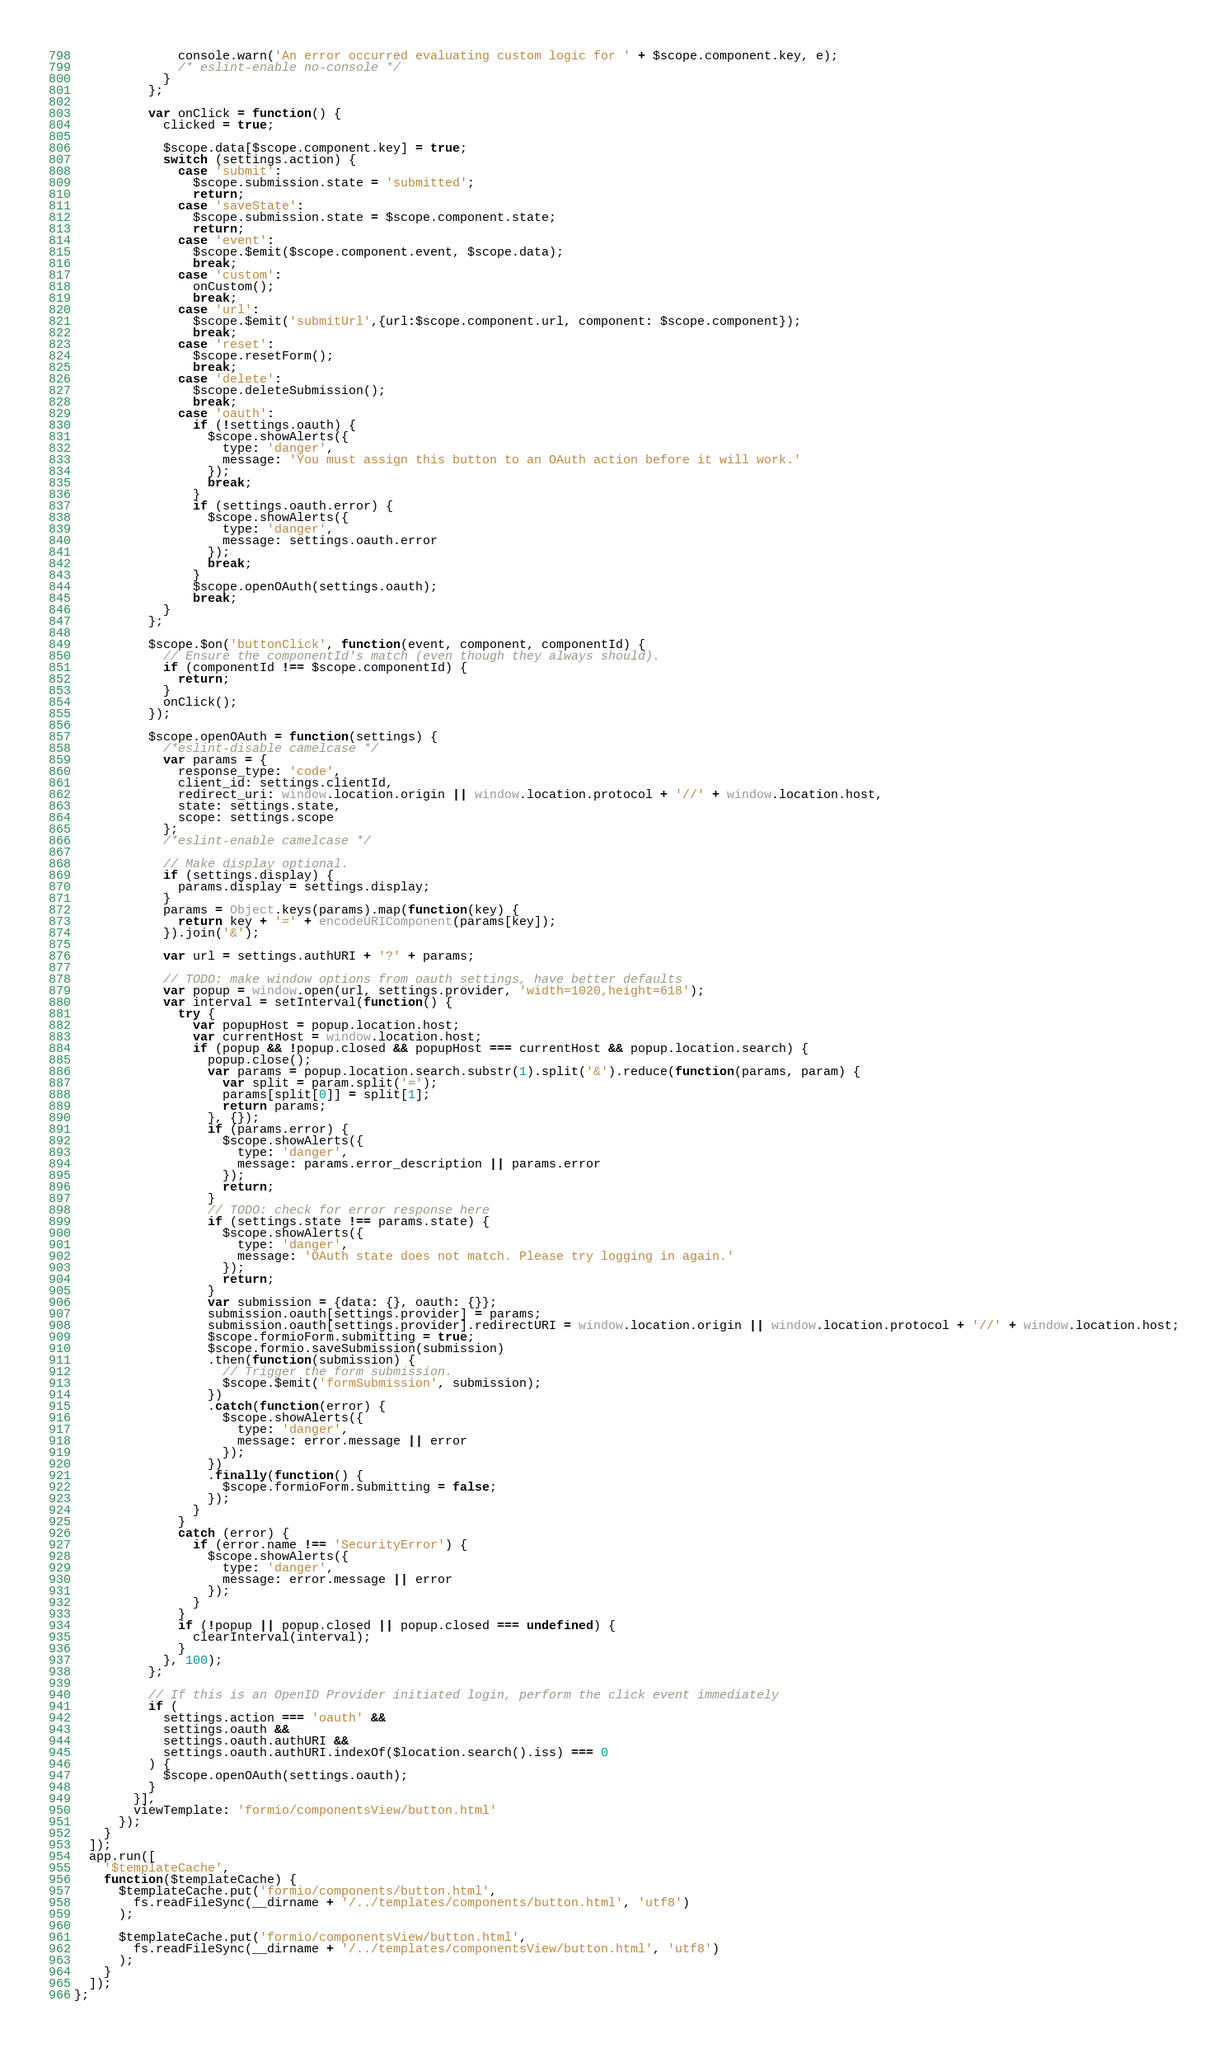<code> <loc_0><loc_0><loc_500><loc_500><_JavaScript_>              console.warn('An error occurred evaluating custom logic for ' + $scope.component.key, e);
              /* eslint-enable no-console */
            }
          };

          var onClick = function() {
            clicked = true;

            $scope.data[$scope.component.key] = true;
            switch (settings.action) {
              case 'submit':
                $scope.submission.state = 'submitted';
                return;
              case 'saveState':
                $scope.submission.state = $scope.component.state;
                return;
              case 'event':
                $scope.$emit($scope.component.event, $scope.data);
                break;
              case 'custom':
                onCustom();
                break;
              case 'url':
                $scope.$emit('submitUrl',{url:$scope.component.url, component: $scope.component});
                break;
              case 'reset':
                $scope.resetForm();
                break;
              case 'delete':
                $scope.deleteSubmission();
                break;
              case 'oauth':
                if (!settings.oauth) {
                  $scope.showAlerts({
                    type: 'danger',
                    message: 'You must assign this button to an OAuth action before it will work.'
                  });
                  break;
                }
                if (settings.oauth.error) {
                  $scope.showAlerts({
                    type: 'danger',
                    message: settings.oauth.error
                  });
                  break;
                }
                $scope.openOAuth(settings.oauth);
                break;
            }
          };

          $scope.$on('buttonClick', function(event, component, componentId) {
            // Ensure the componentId's match (even though they always should).
            if (componentId !== $scope.componentId) {
              return;
            }
            onClick();
          });

          $scope.openOAuth = function(settings) {
            /*eslint-disable camelcase */
            var params = {
              response_type: 'code',
              client_id: settings.clientId,
              redirect_uri: window.location.origin || window.location.protocol + '//' + window.location.host,
              state: settings.state,
              scope: settings.scope
            };
            /*eslint-enable camelcase */

            // Make display optional.
            if (settings.display) {
              params.display = settings.display;
            }
            params = Object.keys(params).map(function(key) {
              return key + '=' + encodeURIComponent(params[key]);
            }).join('&');

            var url = settings.authURI + '?' + params;

            // TODO: make window options from oauth settings, have better defaults
            var popup = window.open(url, settings.provider, 'width=1020,height=618');
            var interval = setInterval(function() {
              try {
                var popupHost = popup.location.host;
                var currentHost = window.location.host;
                if (popup && !popup.closed && popupHost === currentHost && popup.location.search) {
                  popup.close();
                  var params = popup.location.search.substr(1).split('&').reduce(function(params, param) {
                    var split = param.split('=');
                    params[split[0]] = split[1];
                    return params;
                  }, {});
                  if (params.error) {
                    $scope.showAlerts({
                      type: 'danger',
                      message: params.error_description || params.error
                    });
                    return;
                  }
                  // TODO: check for error response here
                  if (settings.state !== params.state) {
                    $scope.showAlerts({
                      type: 'danger',
                      message: 'OAuth state does not match. Please try logging in again.'
                    });
                    return;
                  }
                  var submission = {data: {}, oauth: {}};
                  submission.oauth[settings.provider] = params;
                  submission.oauth[settings.provider].redirectURI = window.location.origin || window.location.protocol + '//' + window.location.host;
                  $scope.formioForm.submitting = true;
                  $scope.formio.saveSubmission(submission)
                  .then(function(submission) {
                    // Trigger the form submission.
                    $scope.$emit('formSubmission', submission);
                  })
                  .catch(function(error) {
                    $scope.showAlerts({
                      type: 'danger',
                      message: error.message || error
                    });
                  })
                  .finally(function() {
                    $scope.formioForm.submitting = false;
                  });
                }
              }
              catch (error) {
                if (error.name !== 'SecurityError') {
                  $scope.showAlerts({
                    type: 'danger',
                    message: error.message || error
                  });
                }
              }
              if (!popup || popup.closed || popup.closed === undefined) {
                clearInterval(interval);
              }
            }, 100);
          };

          // If this is an OpenID Provider initiated login, perform the click event immediately
          if (
            settings.action === 'oauth' &&
            settings.oauth &&
            settings.oauth.authURI &&
            settings.oauth.authURI.indexOf($location.search().iss) === 0
          ) {
            $scope.openOAuth(settings.oauth);
          }
        }],
        viewTemplate: 'formio/componentsView/button.html'
      });
    }
  ]);
  app.run([
    '$templateCache',
    function($templateCache) {
      $templateCache.put('formio/components/button.html',
        fs.readFileSync(__dirname + '/../templates/components/button.html', 'utf8')
      );

      $templateCache.put('formio/componentsView/button.html',
        fs.readFileSync(__dirname + '/../templates/componentsView/button.html', 'utf8')
      );
    }
  ]);
};
</code> 